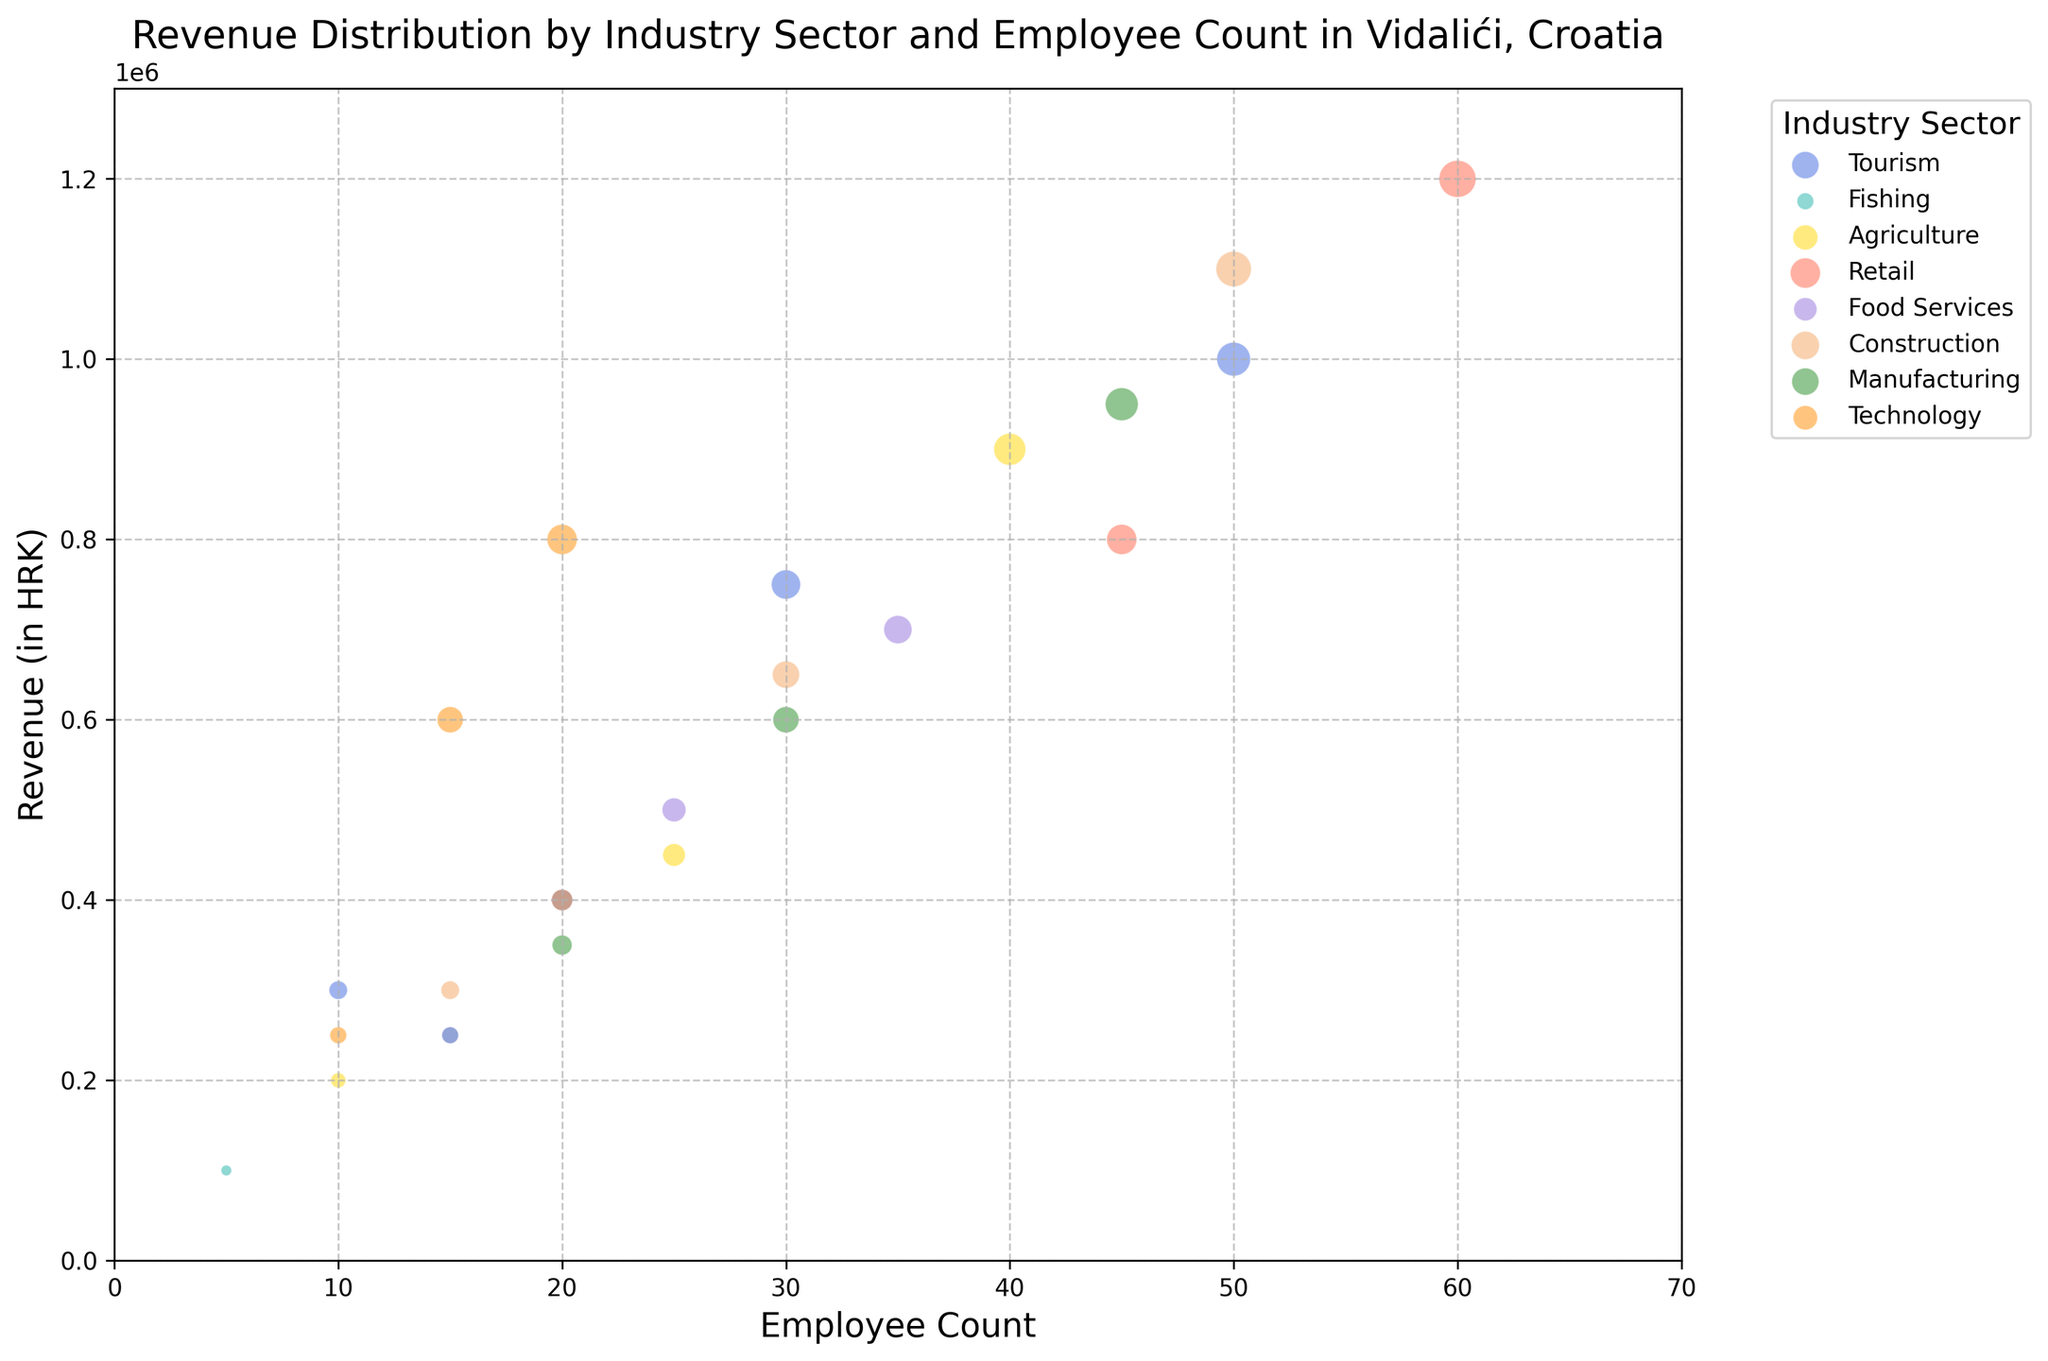Which industry sector has the highest revenue with the smallest employee count? Look for the bubble with the smallest size for each sector and compare their revenues. The smallest employee count for each sector and their corresponding revenue are: Tourism (10, 300,000 HRK), Fishing (5, 100,000 HRK), Agriculture (10, 200,000 HRK), Retail (20, 400,000 HRK), Food Services (15, 250,000 HRK), Construction (15, 300,000 HRK), Manufacturing (20, 350,000 HRK), Technology (10, 250,000 HRK). The highest revenue among these is for Retail (20, 400,000 HRK).
Answer: Retail What is the total revenue for the Technology sector? Identify all the bubbles corresponding to the Technology sector. Sum their revenues: 800,000 HRK + 600,000 HRK + 250,000 HRK = 1,650,000 HRK.
Answer: 1,650,000 HRK Which sector has the largest bubble, and how much revenue does it represent? Locate the largest bubble on the chart and identify its sector and revenue. The largest bubble is in the Retail sector with a revenue of 1,200,000 HRK.
Answer: Retail, 1,200,000 HRK How does the revenue of the largest bubble in Retail compare to the largest bubble in Construction? Identify the largest bubbles in each sector. The largest bubble in Retail has a revenue of 1,200,000 HRK, and the largest bubble in Construction has a revenue of 1,100,000 HRK. Compare the two: 1,200,000 HRK is greater than 1,100,000 HRK.
Answer: Retail's largest bubble has higher revenue Which sector has bubbles with both high employee count and high revenue? Look for sectors with bubbles positioned towards higher values on both axes. Retail has several bubbles in the higher employee count and revenue ranges, e.g., (60, 1,200,000 HRK) and (45, 800,000 HRK), indicating high performance in both metrics.
Answer: Retail 